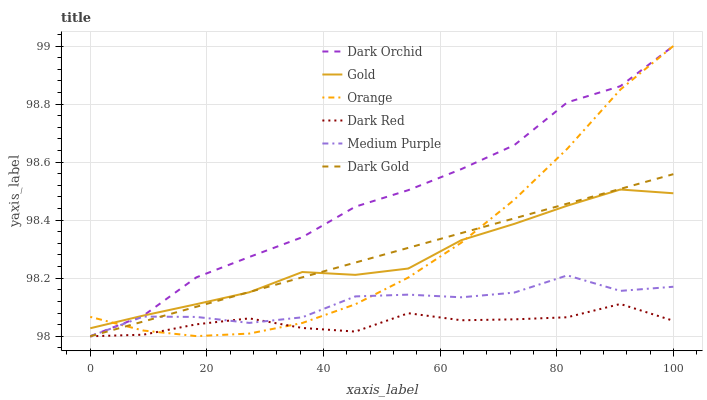Does Dark Gold have the minimum area under the curve?
Answer yes or no. No. Does Dark Gold have the maximum area under the curve?
Answer yes or no. No. Is Dark Red the smoothest?
Answer yes or no. No. Is Dark Red the roughest?
Answer yes or no. No. Does Orange have the lowest value?
Answer yes or no. No. Does Dark Gold have the highest value?
Answer yes or no. No. Is Medium Purple less than Gold?
Answer yes or no. Yes. Is Gold greater than Dark Red?
Answer yes or no. Yes. Does Medium Purple intersect Gold?
Answer yes or no. No. 